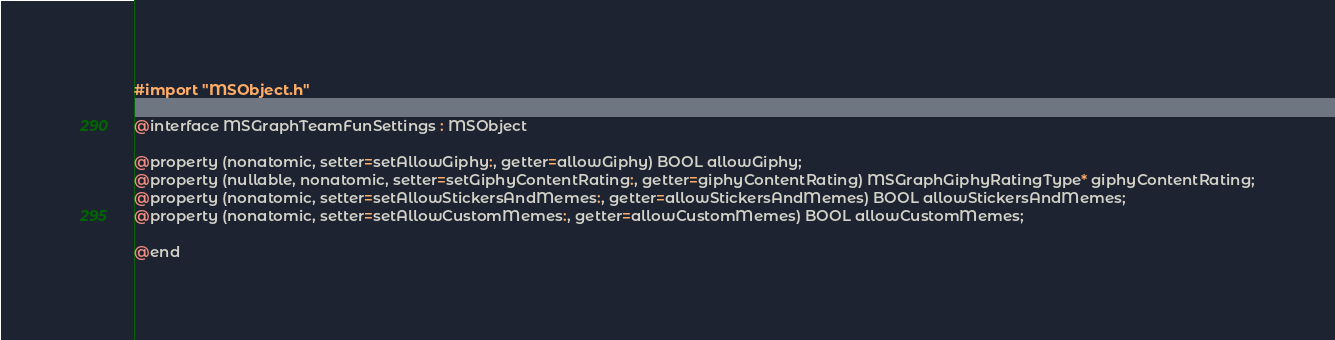Convert code to text. <code><loc_0><loc_0><loc_500><loc_500><_C_>#import "MSObject.h"

@interface MSGraphTeamFunSettings : MSObject

@property (nonatomic, setter=setAllowGiphy:, getter=allowGiphy) BOOL allowGiphy;
@property (nullable, nonatomic, setter=setGiphyContentRating:, getter=giphyContentRating) MSGraphGiphyRatingType* giphyContentRating;
@property (nonatomic, setter=setAllowStickersAndMemes:, getter=allowStickersAndMemes) BOOL allowStickersAndMemes;
@property (nonatomic, setter=setAllowCustomMemes:, getter=allowCustomMemes) BOOL allowCustomMemes;

@end
</code> 